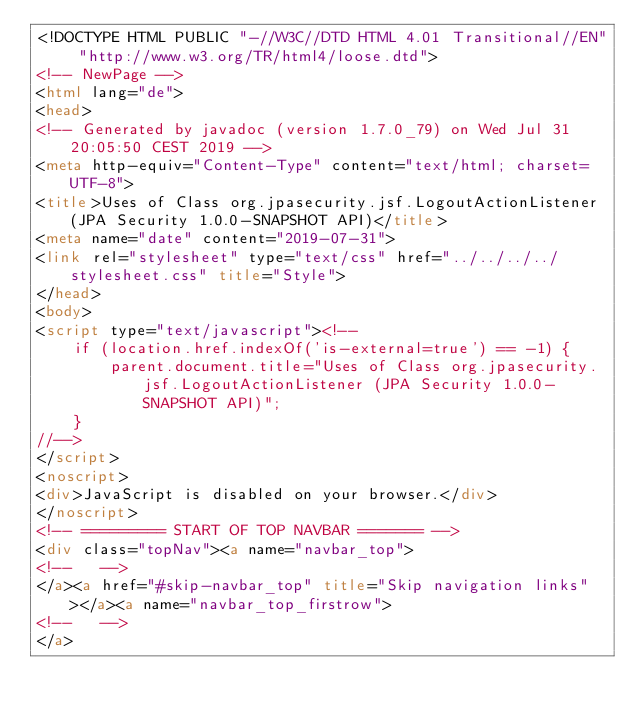<code> <loc_0><loc_0><loc_500><loc_500><_HTML_><!DOCTYPE HTML PUBLIC "-//W3C//DTD HTML 4.01 Transitional//EN" "http://www.w3.org/TR/html4/loose.dtd">
<!-- NewPage -->
<html lang="de">
<head>
<!-- Generated by javadoc (version 1.7.0_79) on Wed Jul 31 20:05:50 CEST 2019 -->
<meta http-equiv="Content-Type" content="text/html; charset=UTF-8">
<title>Uses of Class org.jpasecurity.jsf.LogoutActionListener (JPA Security 1.0.0-SNAPSHOT API)</title>
<meta name="date" content="2019-07-31">
<link rel="stylesheet" type="text/css" href="../../../../stylesheet.css" title="Style">
</head>
<body>
<script type="text/javascript"><!--
    if (location.href.indexOf('is-external=true') == -1) {
        parent.document.title="Uses of Class org.jpasecurity.jsf.LogoutActionListener (JPA Security 1.0.0-SNAPSHOT API)";
    }
//-->
</script>
<noscript>
<div>JavaScript is disabled on your browser.</div>
</noscript>
<!-- ========= START OF TOP NAVBAR ======= -->
<div class="topNav"><a name="navbar_top">
<!--   -->
</a><a href="#skip-navbar_top" title="Skip navigation links"></a><a name="navbar_top_firstrow">
<!--   -->
</a></code> 